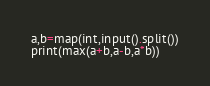Convert code to text. <code><loc_0><loc_0><loc_500><loc_500><_Python_>a,b=map(int,input().split())
print(max(a+b,a-b,a*b))</code> 